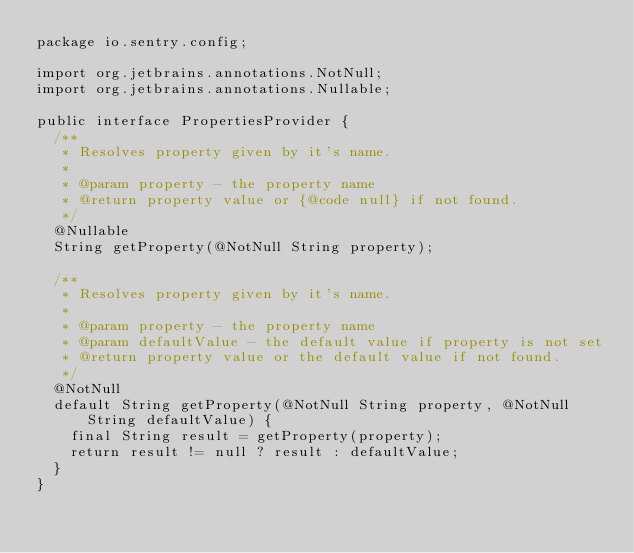Convert code to text. <code><loc_0><loc_0><loc_500><loc_500><_Java_>package io.sentry.config;

import org.jetbrains.annotations.NotNull;
import org.jetbrains.annotations.Nullable;

public interface PropertiesProvider {
  /**
   * Resolves property given by it's name.
   *
   * @param property - the property name
   * @return property value or {@code null} if not found.
   */
  @Nullable
  String getProperty(@NotNull String property);

  /**
   * Resolves property given by it's name.
   *
   * @param property - the property name
   * @param defaultValue - the default value if property is not set
   * @return property value or the default value if not found.
   */
  @NotNull
  default String getProperty(@NotNull String property, @NotNull String defaultValue) {
    final String result = getProperty(property);
    return result != null ? result : defaultValue;
  }
}
</code> 